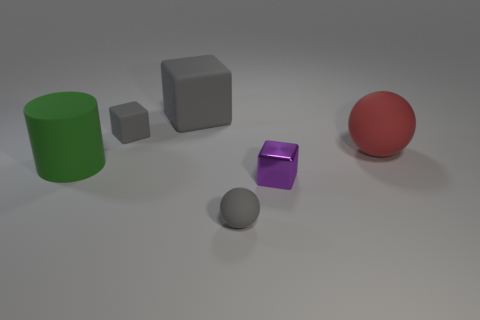Subtract all large rubber cubes. How many cubes are left? 2 Add 4 green cylinders. How many objects exist? 10 Subtract all purple cubes. How many cubes are left? 2 Subtract all cylinders. How many objects are left? 5 Subtract 2 blocks. How many blocks are left? 1 Subtract 0 blue blocks. How many objects are left? 6 Subtract all brown blocks. Subtract all red cylinders. How many blocks are left? 3 Subtract all purple balls. How many blue cylinders are left? 0 Subtract all tiny gray blocks. Subtract all small gray rubber objects. How many objects are left? 3 Add 2 matte cylinders. How many matte cylinders are left? 3 